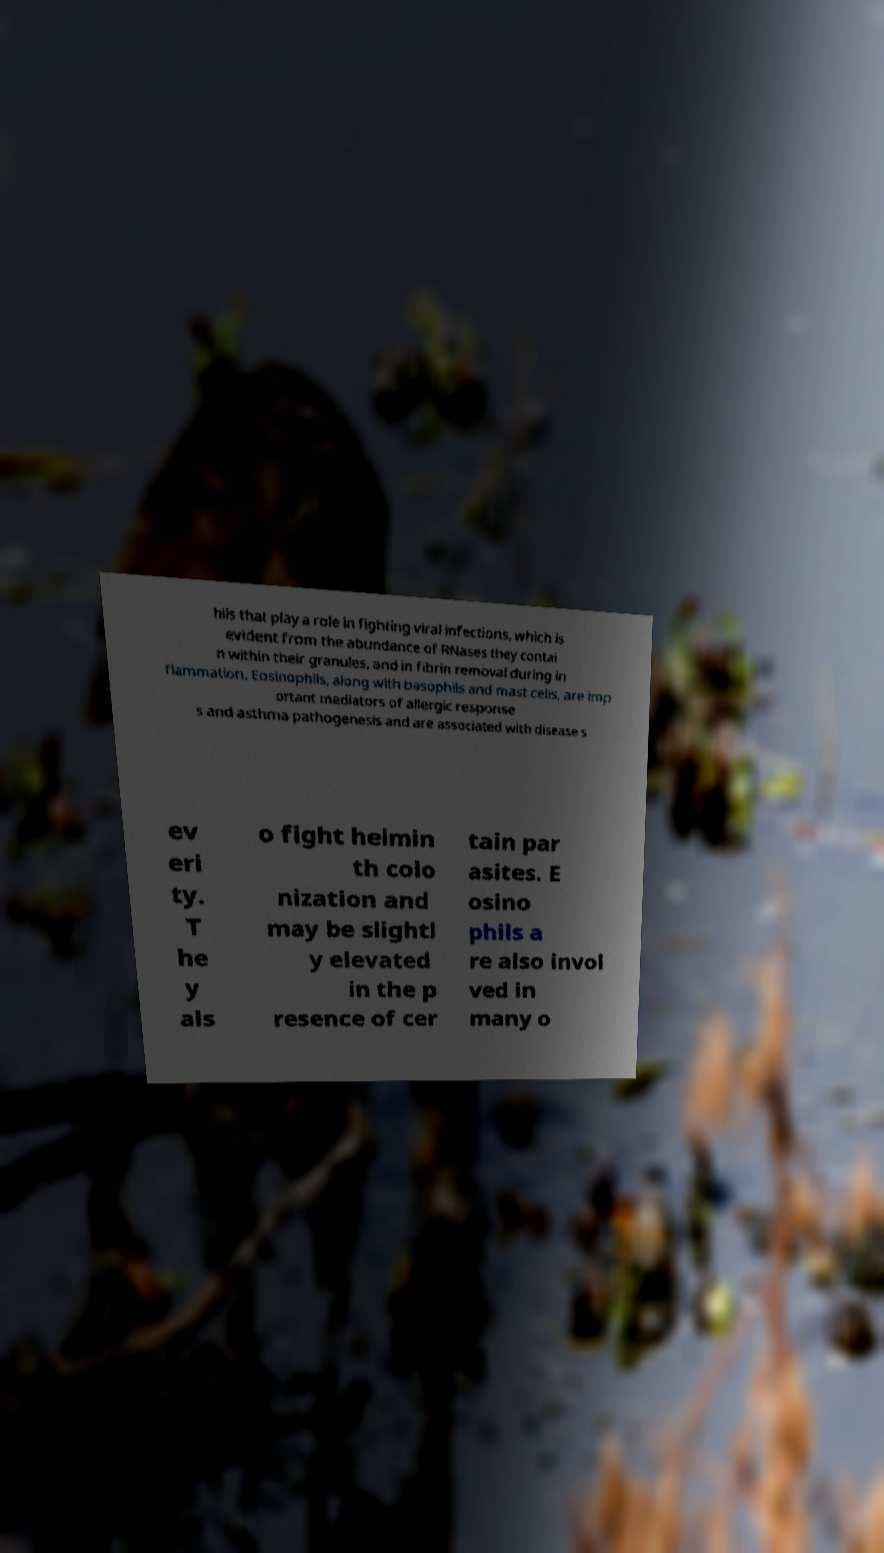Could you assist in decoding the text presented in this image and type it out clearly? hils that play a role in fighting viral infections, which is evident from the abundance of RNases they contai n within their granules, and in fibrin removal during in flammation. Eosinophils, along with basophils and mast cells, are imp ortant mediators of allergic response s and asthma pathogenesis and are associated with disease s ev eri ty. T he y als o fight helmin th colo nization and may be slightl y elevated in the p resence of cer tain par asites. E osino phils a re also invol ved in many o 